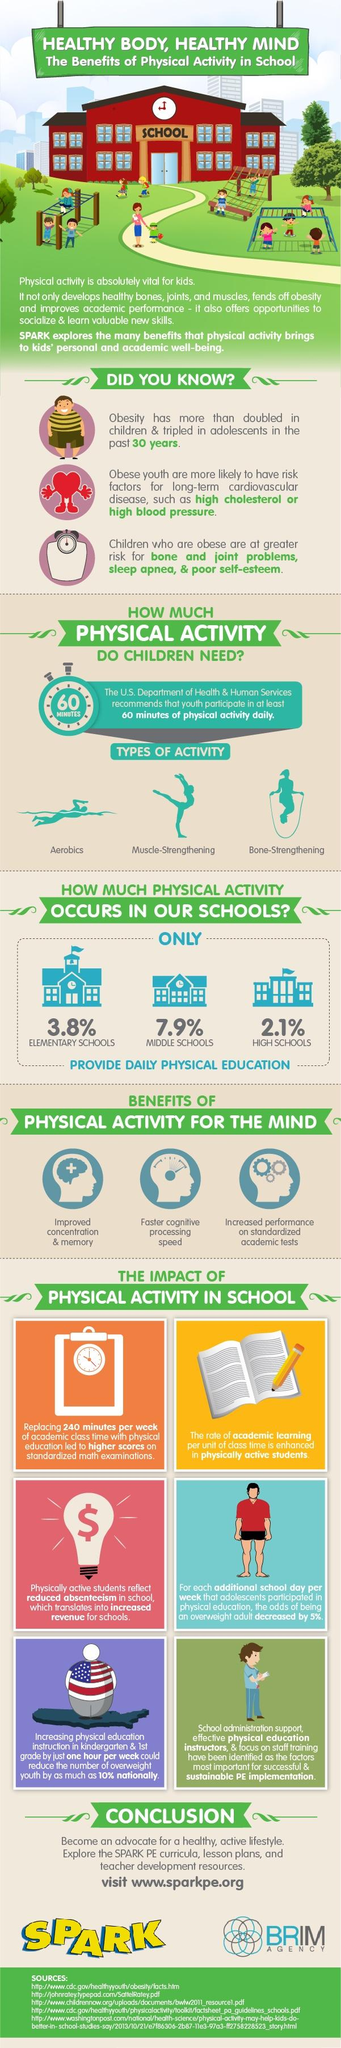List a handful of essential elements in this visual. There are five sources listed at the bottom. 